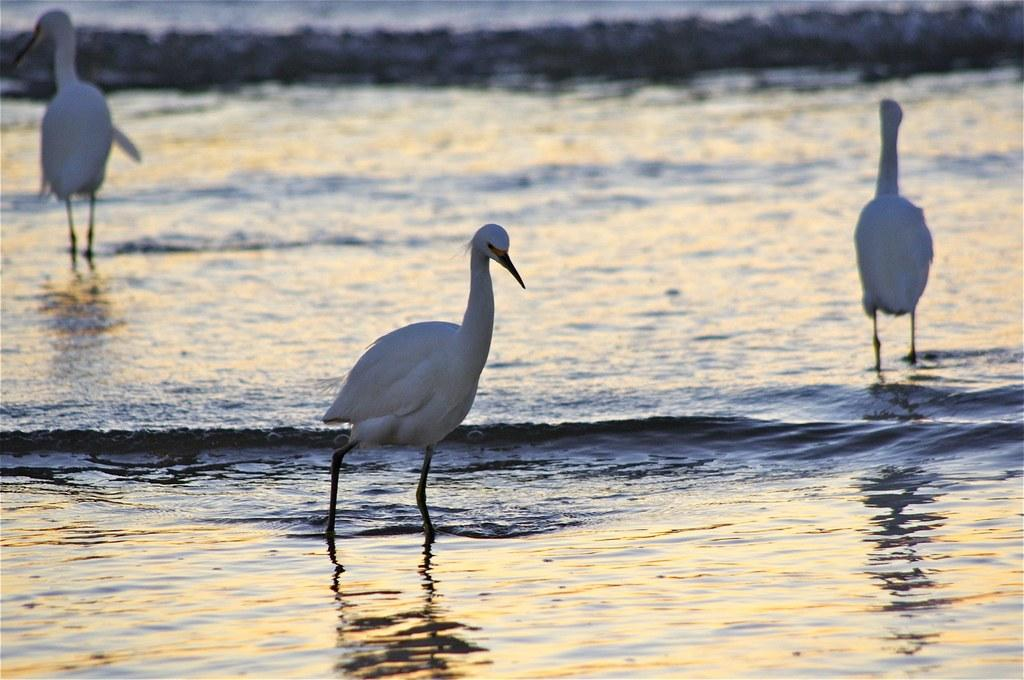What type of animals are in the image? There are cranes in the image. Where are the cranes located? The cranes are standing on the surface of water. What type of leaf is being played on the musical instrument in the image? There is no musical instrument or leaf present in the image; it features cranes standing on water. 